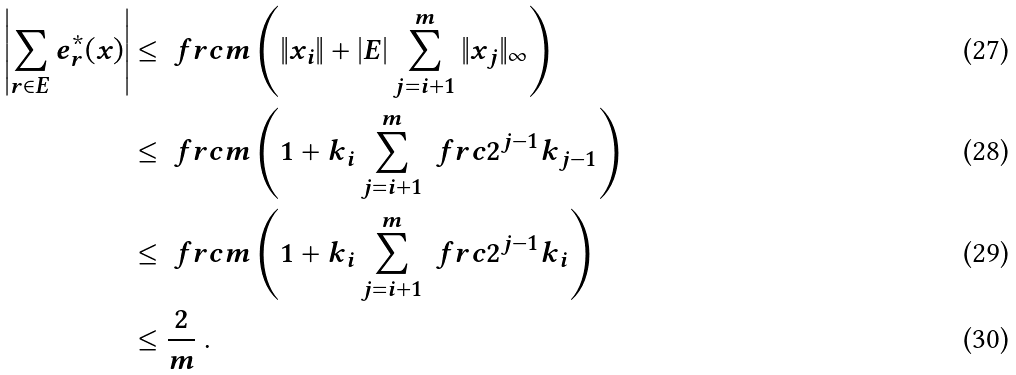Convert formula to latex. <formula><loc_0><loc_0><loc_500><loc_500>\left | \sum _ { r \in E } e ^ { * } _ { r } ( x ) \right | & \leq \ f r c { m } \left ( \| x _ { i } \| + | E | \sum _ { j = i + 1 } ^ { m } \| x _ { j } \| _ { \infty } \right ) \\ & \leq \ f r c { m } \left ( 1 + k _ { i } \sum _ { j = i + 1 } ^ { m } \ f r c { 2 ^ { j - 1 } k _ { j - 1 } } \right ) \\ & \leq \ f r c { m } \left ( 1 + k _ { i } \sum _ { j = i + 1 } ^ { m } \ f r c { 2 ^ { j - 1 } k _ { i } } \right ) \\ & \leq \frac { 2 } { m } \ .</formula> 